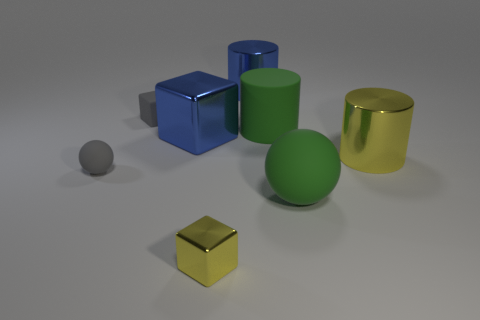Subtract all brown spheres. Subtract all blue blocks. How many spheres are left? 2 Add 1 small yellow shiny objects. How many objects exist? 9 Subtract all blocks. How many objects are left? 5 Subtract all tiny red cylinders. Subtract all tiny yellow cubes. How many objects are left? 7 Add 6 yellow shiny cubes. How many yellow shiny cubes are left? 7 Add 1 gray matte objects. How many gray matte objects exist? 3 Subtract 0 purple blocks. How many objects are left? 8 